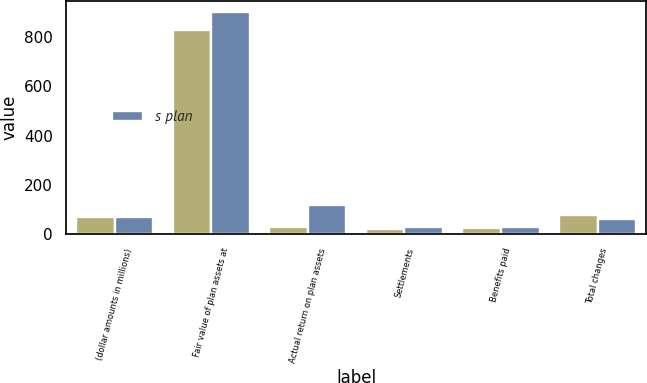<chart> <loc_0><loc_0><loc_500><loc_500><stacked_bar_chart><ecel><fcel>(dollar amounts in millions)<fcel>Fair value of plan assets at<fcel>Actual return on plan assets<fcel>Settlements<fcel>Benefits paid<fcel>Total changes<nl><fcel>nan<fcel>68.5<fcel>828<fcel>30<fcel>19<fcel>26<fcel>75<nl><fcel>s plan<fcel>68.5<fcel>903<fcel>118<fcel>29<fcel>27<fcel>62<nl></chart> 